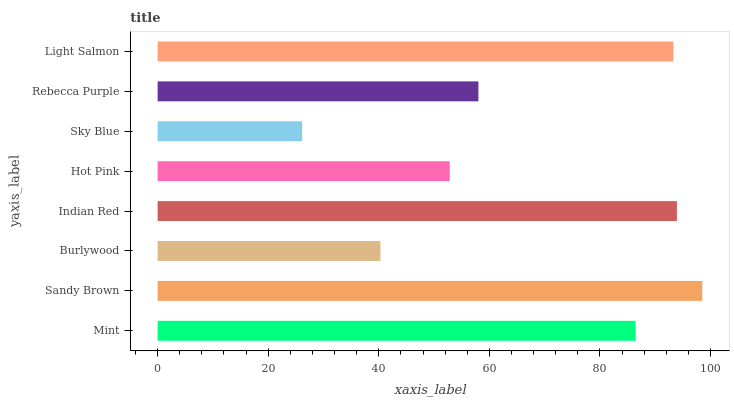Is Sky Blue the minimum?
Answer yes or no. Yes. Is Sandy Brown the maximum?
Answer yes or no. Yes. Is Burlywood the minimum?
Answer yes or no. No. Is Burlywood the maximum?
Answer yes or no. No. Is Sandy Brown greater than Burlywood?
Answer yes or no. Yes. Is Burlywood less than Sandy Brown?
Answer yes or no. Yes. Is Burlywood greater than Sandy Brown?
Answer yes or no. No. Is Sandy Brown less than Burlywood?
Answer yes or no. No. Is Mint the high median?
Answer yes or no. Yes. Is Rebecca Purple the low median?
Answer yes or no. Yes. Is Sandy Brown the high median?
Answer yes or no. No. Is Hot Pink the low median?
Answer yes or no. No. 